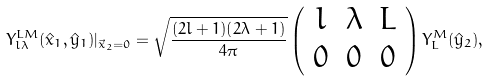<formula> <loc_0><loc_0><loc_500><loc_500>Y _ { l \lambda } ^ { L M } ( \hat { x } _ { 1 } , \hat { y } _ { 1 } ) | _ { \vec { x } _ { 2 } = 0 } = \sqrt { \frac { ( 2 l + 1 ) ( 2 \lambda + 1 ) } { 4 \pi } } \left ( \begin{array} { c c c } l & \lambda & L \\ 0 & 0 & 0 \end{array} \right ) Y _ { L } ^ { M } ( \hat { y } _ { 2 } ) ,</formula> 